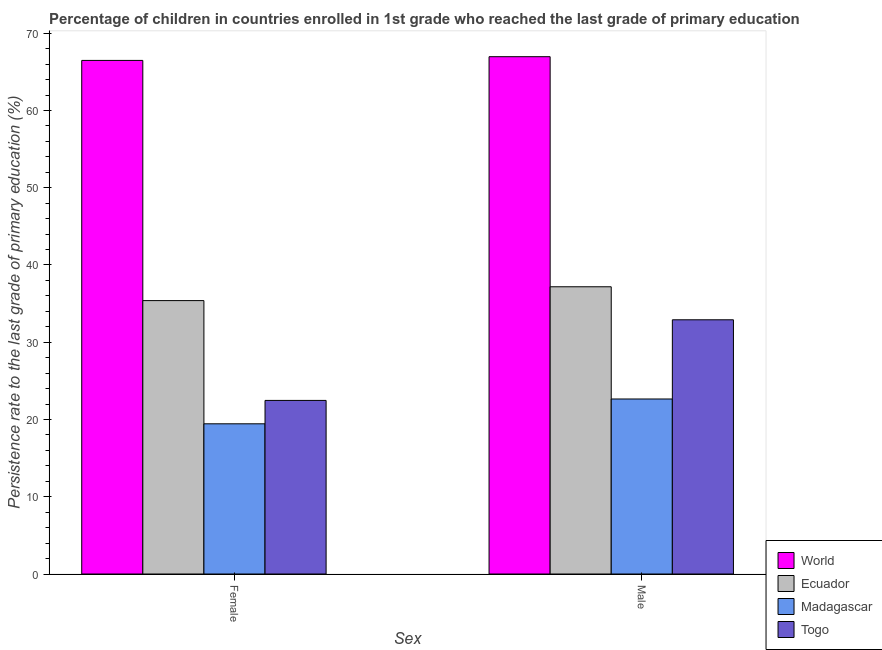Are the number of bars per tick equal to the number of legend labels?
Give a very brief answer. Yes. How many bars are there on the 1st tick from the right?
Give a very brief answer. 4. What is the persistence rate of male students in Togo?
Offer a terse response. 32.91. Across all countries, what is the maximum persistence rate of male students?
Your response must be concise. 66.96. Across all countries, what is the minimum persistence rate of female students?
Your answer should be very brief. 19.44. In which country was the persistence rate of female students minimum?
Offer a very short reply. Madagascar. What is the total persistence rate of female students in the graph?
Make the answer very short. 143.78. What is the difference between the persistence rate of female students in World and that in Ecuador?
Your answer should be compact. 31.09. What is the difference between the persistence rate of male students in Ecuador and the persistence rate of female students in Togo?
Keep it short and to the point. 14.71. What is the average persistence rate of female students per country?
Offer a very short reply. 35.94. What is the difference between the persistence rate of female students and persistence rate of male students in Togo?
Provide a succinct answer. -10.44. In how many countries, is the persistence rate of male students greater than 56 %?
Keep it short and to the point. 1. What is the ratio of the persistence rate of female students in Ecuador to that in Madagascar?
Provide a short and direct response. 1.82. Is the persistence rate of male students in World less than that in Ecuador?
Make the answer very short. No. In how many countries, is the persistence rate of female students greater than the average persistence rate of female students taken over all countries?
Your answer should be compact. 1. What does the 3rd bar from the left in Female represents?
Keep it short and to the point. Madagascar. What does the 1st bar from the right in Female represents?
Ensure brevity in your answer.  Togo. How many bars are there?
Your response must be concise. 8. Are all the bars in the graph horizontal?
Provide a short and direct response. No. How many countries are there in the graph?
Provide a succinct answer. 4. Are the values on the major ticks of Y-axis written in scientific E-notation?
Give a very brief answer. No. Does the graph contain grids?
Offer a terse response. No. Where does the legend appear in the graph?
Your answer should be very brief. Bottom right. How many legend labels are there?
Your answer should be compact. 4. What is the title of the graph?
Keep it short and to the point. Percentage of children in countries enrolled in 1st grade who reached the last grade of primary education. Does "Bahrain" appear as one of the legend labels in the graph?
Offer a very short reply. No. What is the label or title of the X-axis?
Offer a very short reply. Sex. What is the label or title of the Y-axis?
Give a very brief answer. Persistence rate to the last grade of primary education (%). What is the Persistence rate to the last grade of primary education (%) in World in Female?
Your response must be concise. 66.48. What is the Persistence rate to the last grade of primary education (%) of Ecuador in Female?
Your response must be concise. 35.39. What is the Persistence rate to the last grade of primary education (%) in Madagascar in Female?
Your answer should be compact. 19.44. What is the Persistence rate to the last grade of primary education (%) in Togo in Female?
Provide a short and direct response. 22.47. What is the Persistence rate to the last grade of primary education (%) in World in Male?
Your answer should be compact. 66.96. What is the Persistence rate to the last grade of primary education (%) of Ecuador in Male?
Give a very brief answer. 37.18. What is the Persistence rate to the last grade of primary education (%) in Madagascar in Male?
Ensure brevity in your answer.  22.65. What is the Persistence rate to the last grade of primary education (%) of Togo in Male?
Your answer should be compact. 32.91. Across all Sex, what is the maximum Persistence rate to the last grade of primary education (%) in World?
Your answer should be very brief. 66.96. Across all Sex, what is the maximum Persistence rate to the last grade of primary education (%) of Ecuador?
Offer a terse response. 37.18. Across all Sex, what is the maximum Persistence rate to the last grade of primary education (%) in Madagascar?
Offer a terse response. 22.65. Across all Sex, what is the maximum Persistence rate to the last grade of primary education (%) of Togo?
Your response must be concise. 32.91. Across all Sex, what is the minimum Persistence rate to the last grade of primary education (%) in World?
Give a very brief answer. 66.48. Across all Sex, what is the minimum Persistence rate to the last grade of primary education (%) of Ecuador?
Your answer should be compact. 35.39. Across all Sex, what is the minimum Persistence rate to the last grade of primary education (%) of Madagascar?
Make the answer very short. 19.44. Across all Sex, what is the minimum Persistence rate to the last grade of primary education (%) of Togo?
Make the answer very short. 22.47. What is the total Persistence rate to the last grade of primary education (%) in World in the graph?
Offer a very short reply. 133.44. What is the total Persistence rate to the last grade of primary education (%) of Ecuador in the graph?
Ensure brevity in your answer.  72.57. What is the total Persistence rate to the last grade of primary education (%) of Madagascar in the graph?
Provide a succinct answer. 42.1. What is the total Persistence rate to the last grade of primary education (%) of Togo in the graph?
Keep it short and to the point. 55.37. What is the difference between the Persistence rate to the last grade of primary education (%) in World in Female and that in Male?
Your answer should be compact. -0.48. What is the difference between the Persistence rate to the last grade of primary education (%) of Ecuador in Female and that in Male?
Offer a very short reply. -1.79. What is the difference between the Persistence rate to the last grade of primary education (%) in Madagascar in Female and that in Male?
Provide a succinct answer. -3.21. What is the difference between the Persistence rate to the last grade of primary education (%) in Togo in Female and that in Male?
Provide a short and direct response. -10.44. What is the difference between the Persistence rate to the last grade of primary education (%) of World in Female and the Persistence rate to the last grade of primary education (%) of Ecuador in Male?
Give a very brief answer. 29.3. What is the difference between the Persistence rate to the last grade of primary education (%) of World in Female and the Persistence rate to the last grade of primary education (%) of Madagascar in Male?
Give a very brief answer. 43.83. What is the difference between the Persistence rate to the last grade of primary education (%) of World in Female and the Persistence rate to the last grade of primary education (%) of Togo in Male?
Provide a succinct answer. 33.58. What is the difference between the Persistence rate to the last grade of primary education (%) of Ecuador in Female and the Persistence rate to the last grade of primary education (%) of Madagascar in Male?
Your answer should be compact. 12.73. What is the difference between the Persistence rate to the last grade of primary education (%) in Ecuador in Female and the Persistence rate to the last grade of primary education (%) in Togo in Male?
Offer a very short reply. 2.48. What is the difference between the Persistence rate to the last grade of primary education (%) in Madagascar in Female and the Persistence rate to the last grade of primary education (%) in Togo in Male?
Provide a succinct answer. -13.46. What is the average Persistence rate to the last grade of primary education (%) of World per Sex?
Make the answer very short. 66.72. What is the average Persistence rate to the last grade of primary education (%) of Ecuador per Sex?
Your answer should be compact. 36.28. What is the average Persistence rate to the last grade of primary education (%) in Madagascar per Sex?
Provide a short and direct response. 21.05. What is the average Persistence rate to the last grade of primary education (%) in Togo per Sex?
Make the answer very short. 27.69. What is the difference between the Persistence rate to the last grade of primary education (%) of World and Persistence rate to the last grade of primary education (%) of Ecuador in Female?
Provide a succinct answer. 31.09. What is the difference between the Persistence rate to the last grade of primary education (%) of World and Persistence rate to the last grade of primary education (%) of Madagascar in Female?
Your answer should be very brief. 47.04. What is the difference between the Persistence rate to the last grade of primary education (%) in World and Persistence rate to the last grade of primary education (%) in Togo in Female?
Give a very brief answer. 44.01. What is the difference between the Persistence rate to the last grade of primary education (%) in Ecuador and Persistence rate to the last grade of primary education (%) in Madagascar in Female?
Ensure brevity in your answer.  15.95. What is the difference between the Persistence rate to the last grade of primary education (%) of Ecuador and Persistence rate to the last grade of primary education (%) of Togo in Female?
Provide a succinct answer. 12.92. What is the difference between the Persistence rate to the last grade of primary education (%) of Madagascar and Persistence rate to the last grade of primary education (%) of Togo in Female?
Give a very brief answer. -3.03. What is the difference between the Persistence rate to the last grade of primary education (%) of World and Persistence rate to the last grade of primary education (%) of Ecuador in Male?
Your response must be concise. 29.78. What is the difference between the Persistence rate to the last grade of primary education (%) of World and Persistence rate to the last grade of primary education (%) of Madagascar in Male?
Ensure brevity in your answer.  44.31. What is the difference between the Persistence rate to the last grade of primary education (%) of World and Persistence rate to the last grade of primary education (%) of Togo in Male?
Your answer should be very brief. 34.06. What is the difference between the Persistence rate to the last grade of primary education (%) of Ecuador and Persistence rate to the last grade of primary education (%) of Madagascar in Male?
Your answer should be compact. 14.52. What is the difference between the Persistence rate to the last grade of primary education (%) in Ecuador and Persistence rate to the last grade of primary education (%) in Togo in Male?
Provide a short and direct response. 4.27. What is the difference between the Persistence rate to the last grade of primary education (%) of Madagascar and Persistence rate to the last grade of primary education (%) of Togo in Male?
Your response must be concise. -10.25. What is the ratio of the Persistence rate to the last grade of primary education (%) of World in Female to that in Male?
Make the answer very short. 0.99. What is the ratio of the Persistence rate to the last grade of primary education (%) in Ecuador in Female to that in Male?
Provide a short and direct response. 0.95. What is the ratio of the Persistence rate to the last grade of primary education (%) in Madagascar in Female to that in Male?
Provide a short and direct response. 0.86. What is the ratio of the Persistence rate to the last grade of primary education (%) in Togo in Female to that in Male?
Offer a very short reply. 0.68. What is the difference between the highest and the second highest Persistence rate to the last grade of primary education (%) in World?
Offer a terse response. 0.48. What is the difference between the highest and the second highest Persistence rate to the last grade of primary education (%) in Ecuador?
Give a very brief answer. 1.79. What is the difference between the highest and the second highest Persistence rate to the last grade of primary education (%) of Madagascar?
Offer a terse response. 3.21. What is the difference between the highest and the second highest Persistence rate to the last grade of primary education (%) of Togo?
Provide a short and direct response. 10.44. What is the difference between the highest and the lowest Persistence rate to the last grade of primary education (%) of World?
Offer a very short reply. 0.48. What is the difference between the highest and the lowest Persistence rate to the last grade of primary education (%) of Ecuador?
Provide a short and direct response. 1.79. What is the difference between the highest and the lowest Persistence rate to the last grade of primary education (%) in Madagascar?
Offer a terse response. 3.21. What is the difference between the highest and the lowest Persistence rate to the last grade of primary education (%) of Togo?
Make the answer very short. 10.44. 